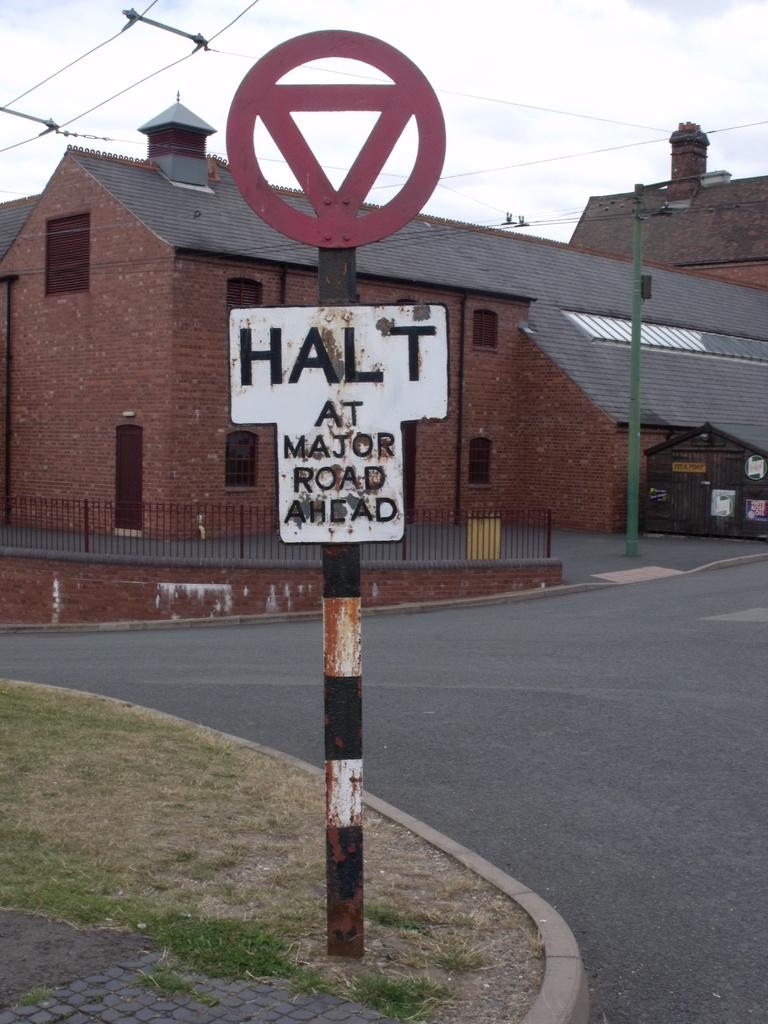<image>
Create a compact narrative representing the image presented. A warning sign on a street directs motorists to halt at a major road ahead. 